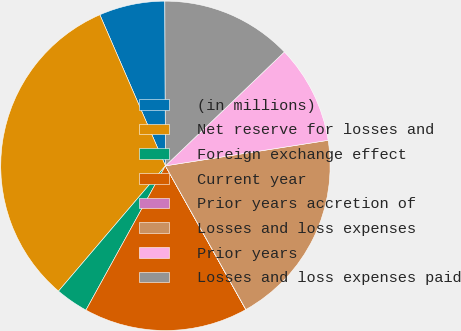Convert chart to OTSL. <chart><loc_0><loc_0><loc_500><loc_500><pie_chart><fcel>(in millions)<fcel>Net reserve for losses and<fcel>Foreign exchange effect<fcel>Current year<fcel>Prior years accretion of<fcel>Losses and loss expenses<fcel>Prior years<fcel>Losses and loss expenses paid<nl><fcel>6.46%<fcel>32.24%<fcel>3.23%<fcel>16.13%<fcel>0.01%<fcel>19.35%<fcel>9.68%<fcel>12.9%<nl></chart> 